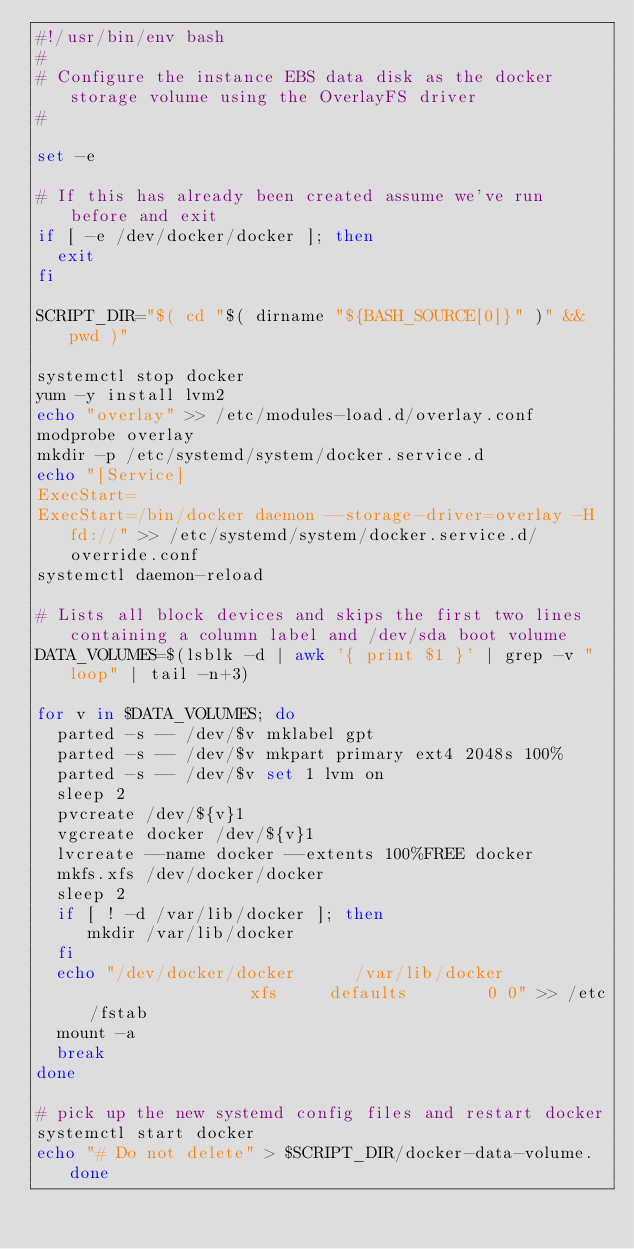Convert code to text. <code><loc_0><loc_0><loc_500><loc_500><_Bash_>#!/usr/bin/env bash
#
# Configure the instance EBS data disk as the docker storage volume using the OverlayFS driver
#

set -e

# If this has already been created assume we've run before and exit
if [ -e /dev/docker/docker ]; then
  exit
fi

SCRIPT_DIR="$( cd "$( dirname "${BASH_SOURCE[0]}" )" && pwd )"

systemctl stop docker
yum -y install lvm2
echo "overlay" >> /etc/modules-load.d/overlay.conf
modprobe overlay
mkdir -p /etc/systemd/system/docker.service.d
echo "[Service]
ExecStart=
ExecStart=/bin/docker daemon --storage-driver=overlay -H fd://" >> /etc/systemd/system/docker.service.d/override.conf
systemctl daemon-reload

# Lists all block devices and skips the first two lines containing a column label and /dev/sda boot volume
DATA_VOLUMES=$(lsblk -d | awk '{ print $1 }' | grep -v "loop" | tail -n+3)

for v in $DATA_VOLUMES; do
  parted -s -- /dev/$v mklabel gpt
  parted -s -- /dev/$v mkpart primary ext4 2048s 100%
  parted -s -- /dev/$v set 1 lvm on
  sleep 2
  pvcreate /dev/${v}1
  vgcreate docker /dev/${v}1
  lvcreate --name docker --extents 100%FREE docker
  mkfs.xfs /dev/docker/docker
  sleep 2
  if [ ! -d /var/lib/docker ]; then
     mkdir /var/lib/docker
  fi
  echo "/dev/docker/docker      /var/lib/docker                 xfs     defaults        0 0" >> /etc/fstab
  mount -a
  break
done

# pick up the new systemd config files and restart docker
systemctl start docker
echo "# Do not delete" > $SCRIPT_DIR/docker-data-volume.done
</code> 